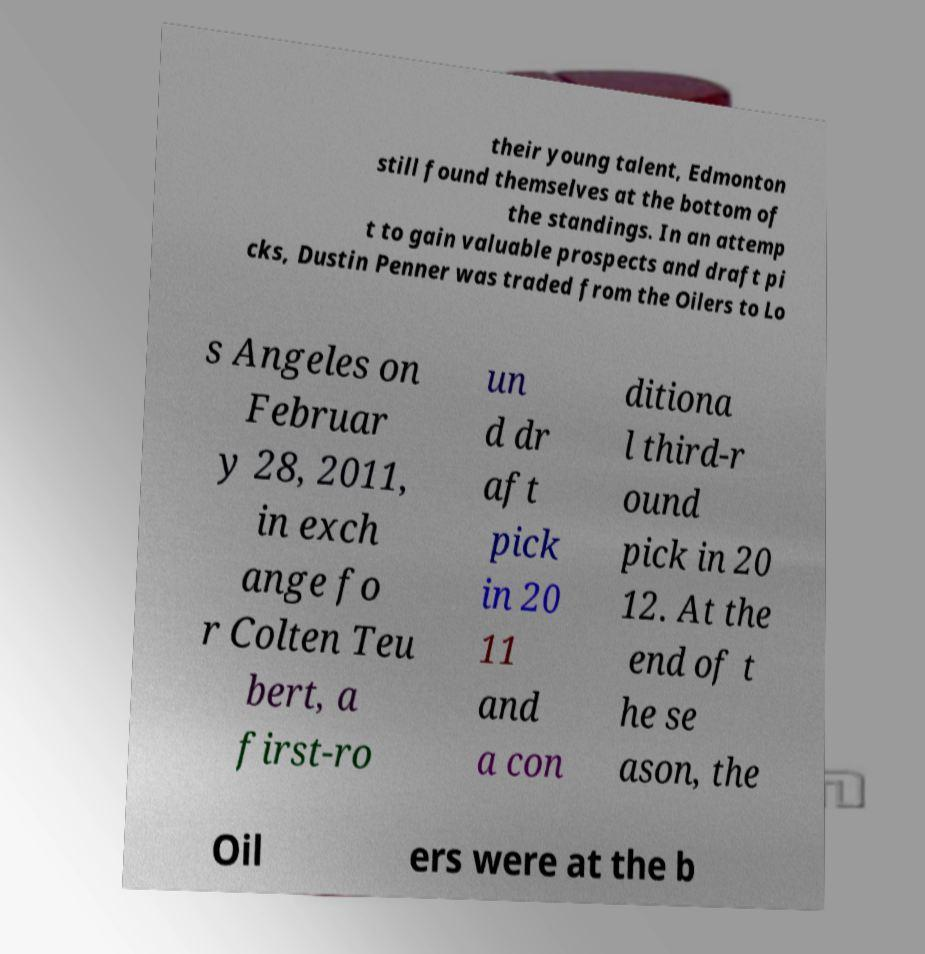Could you assist in decoding the text presented in this image and type it out clearly? their young talent, Edmonton still found themselves at the bottom of the standings. In an attemp t to gain valuable prospects and draft pi cks, Dustin Penner was traded from the Oilers to Lo s Angeles on Februar y 28, 2011, in exch ange fo r Colten Teu bert, a first-ro un d dr aft pick in 20 11 and a con ditiona l third-r ound pick in 20 12. At the end of t he se ason, the Oil ers were at the b 